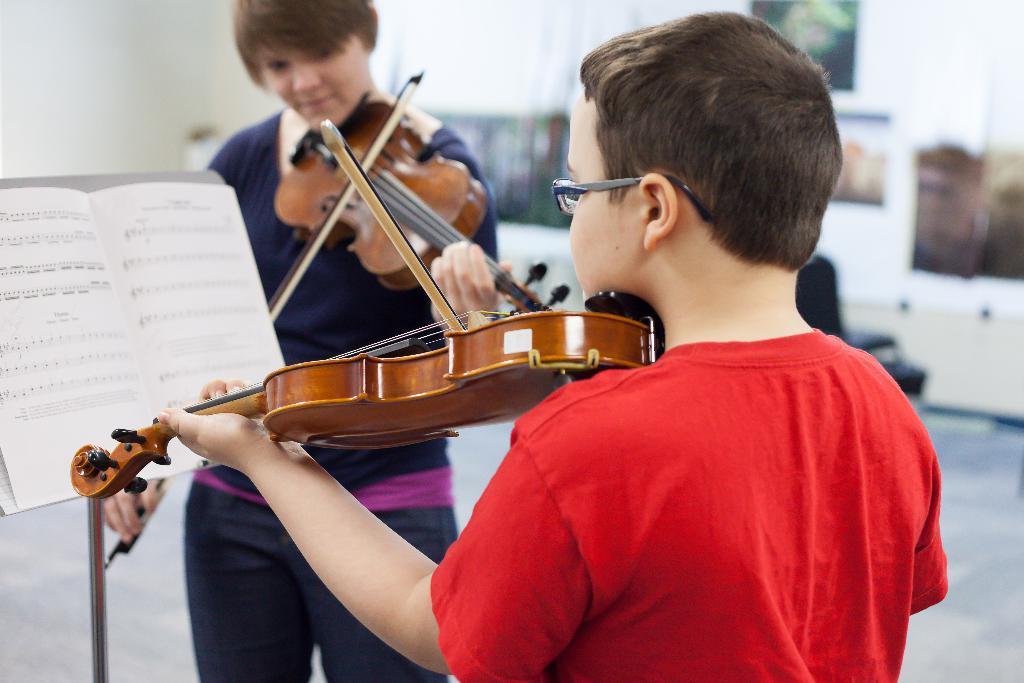In one or two sentences, can you explain what this image depicts? As we can see in the image there is a wall, photo frames, two people holding guitars and there is a book. 